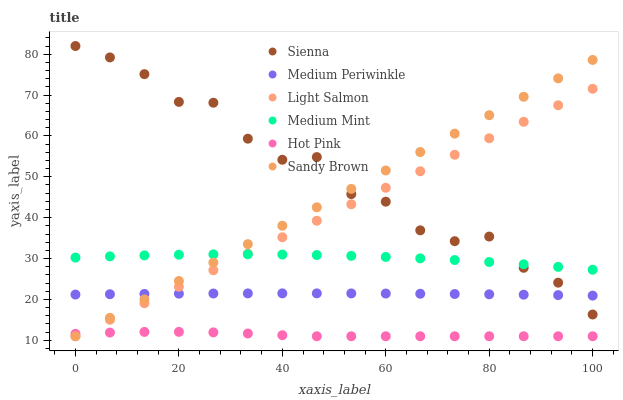Does Hot Pink have the minimum area under the curve?
Answer yes or no. Yes. Does Sienna have the maximum area under the curve?
Answer yes or no. Yes. Does Light Salmon have the minimum area under the curve?
Answer yes or no. No. Does Light Salmon have the maximum area under the curve?
Answer yes or no. No. Is Light Salmon the smoothest?
Answer yes or no. Yes. Is Sienna the roughest?
Answer yes or no. Yes. Is Hot Pink the smoothest?
Answer yes or no. No. Is Hot Pink the roughest?
Answer yes or no. No. Does Light Salmon have the lowest value?
Answer yes or no. Yes. Does Medium Periwinkle have the lowest value?
Answer yes or no. No. Does Sienna have the highest value?
Answer yes or no. Yes. Does Light Salmon have the highest value?
Answer yes or no. No. Is Medium Periwinkle less than Medium Mint?
Answer yes or no. Yes. Is Medium Periwinkle greater than Hot Pink?
Answer yes or no. Yes. Does Medium Mint intersect Sienna?
Answer yes or no. Yes. Is Medium Mint less than Sienna?
Answer yes or no. No. Is Medium Mint greater than Sienna?
Answer yes or no. No. Does Medium Periwinkle intersect Medium Mint?
Answer yes or no. No. 